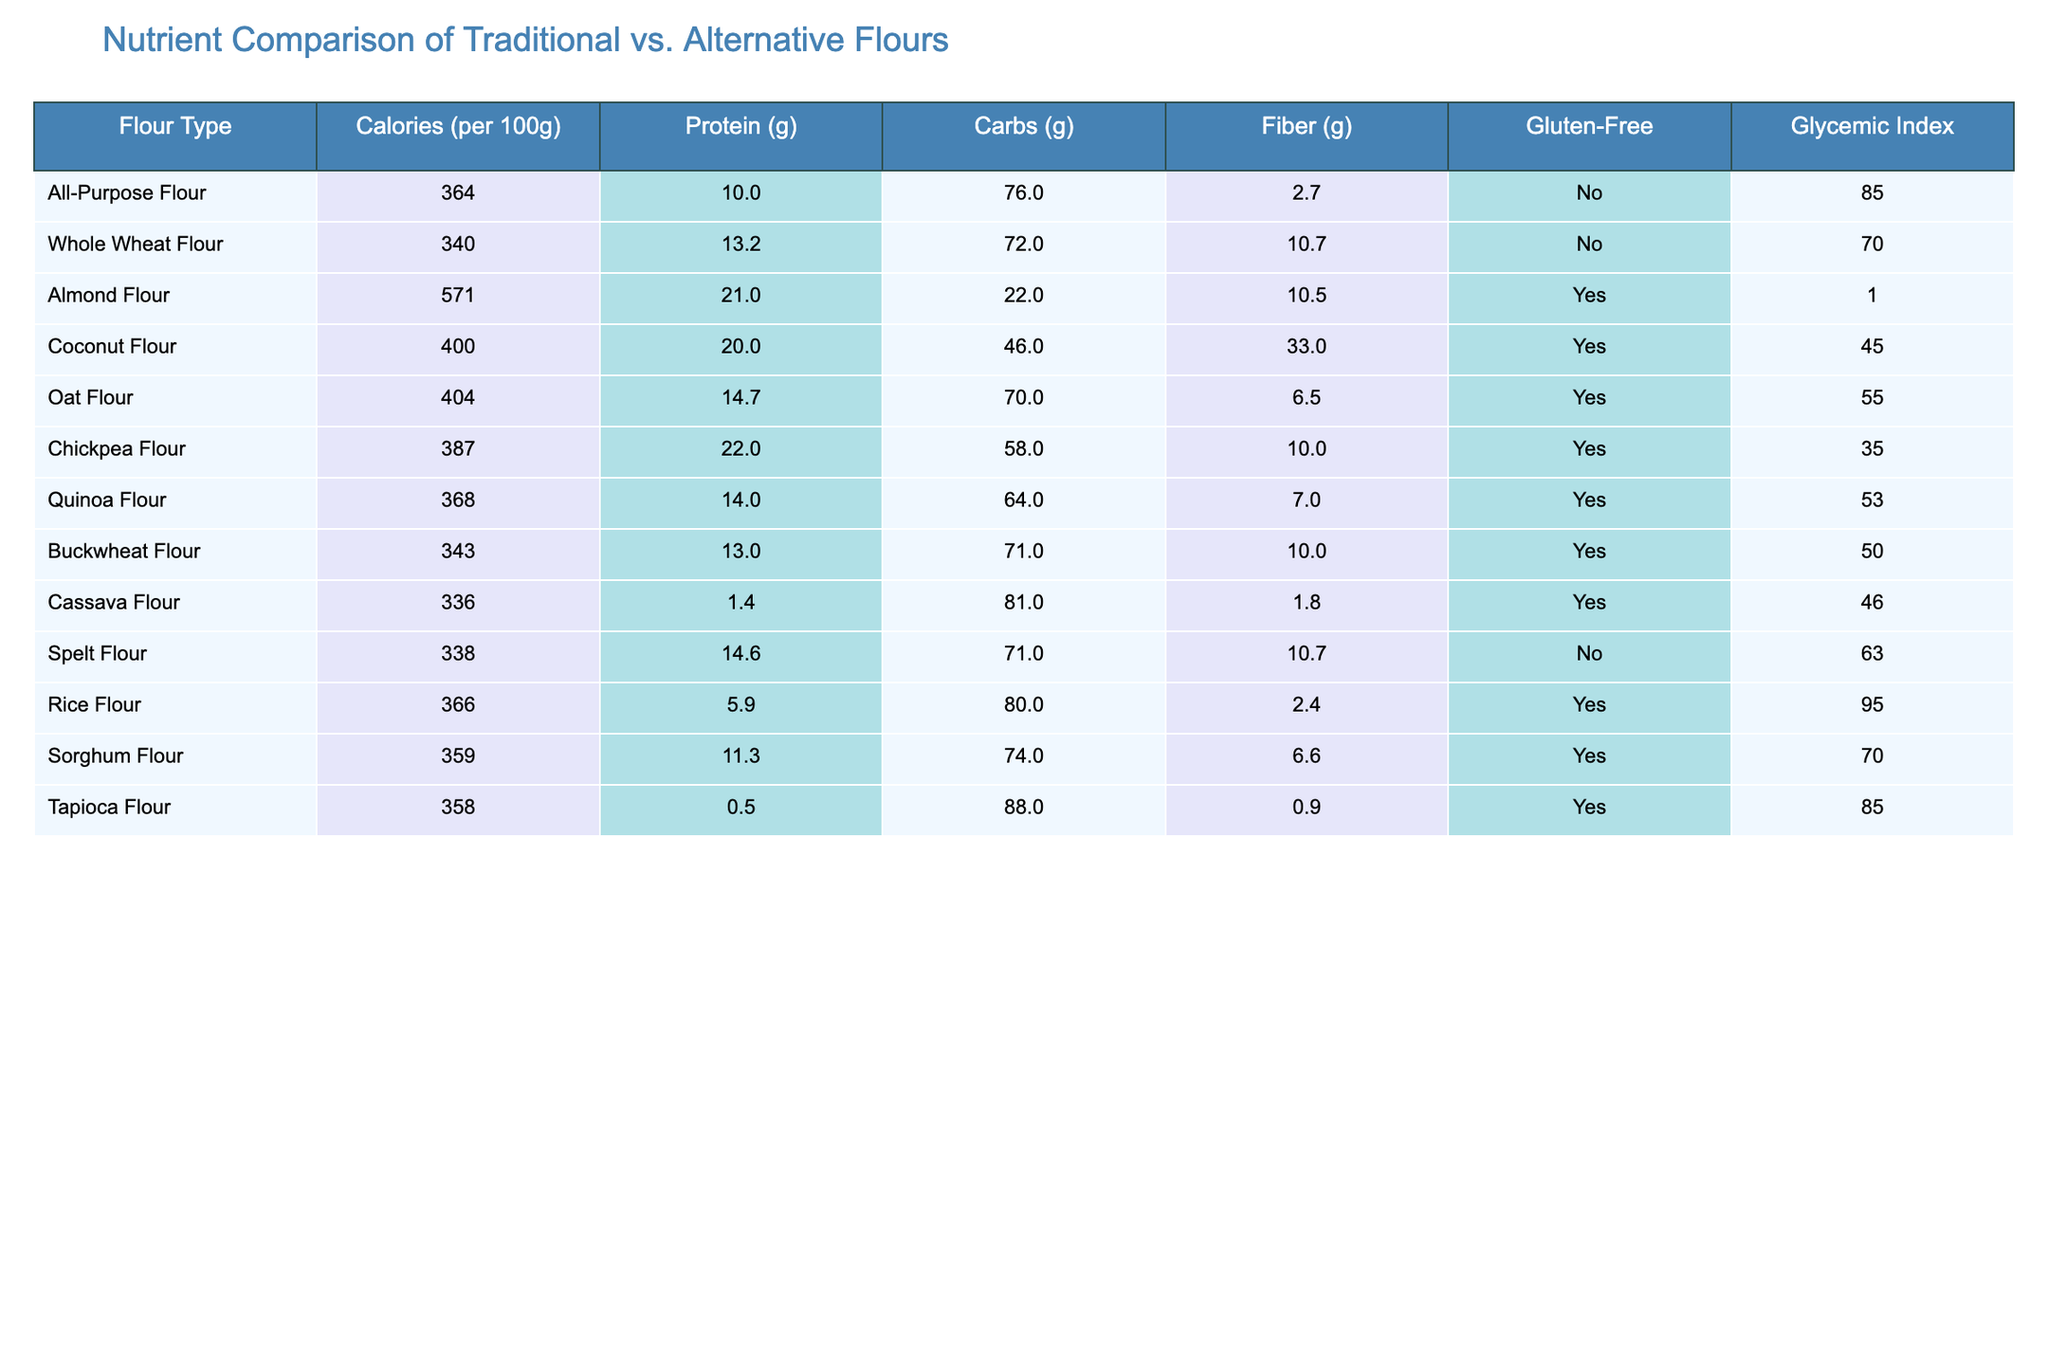What is the calorie content of Almond Flour? According to the table, Almond Flour has a calorie content of 571 calories per 100g.
Answer: 571 Which flour has the highest protein content? The table shows that Almond Flour has the highest protein content at 21g per 100g, compared to the other flours listed.
Answer: Almond Flour Is Coconut Flour gluten-free? The table indicates that Coconut Flour is labeled as gluten-free.
Answer: Yes What is the average glycemic index of the flours listed? To find the average glycemic index, sum the glycemic indices of all flours (85 + 70 + 1 + 45 + 55 + 35 + 53 + 50 + 46 + 63 + 95 + 70 + 85 =  588) and divide by the number of flours (13). Therefore, 588/13 ≈ 45.23.
Answer: 45.23 Which flour type has the lowest carbohydrate content? Analyzing the carbohydrates listed, Almond Flour has 22g, which is the lowest amount compared to other flours listed.
Answer: Almond Flour Is Rice Flour the only flour with a glycemic index higher than 90? The table shows that Rice Flour has a glycemic index of 95 and none of the other flours have a glycemic index above this value, making this statement true.
Answer: Yes What is the difference in fiber content between Whole Wheat Flour and Chickpea Flour? Whole Wheat Flour has 10.7g of fiber, while Chickpea Flour has 10g. The difference is 10.7g - 10g = 0.7g.
Answer: 0.7g How many flours listed are gluten-free? The table specifies 8 out of the 13 flours are marked as gluten-free.
Answer: 8 What flour has the highest calorie content, and what is its fiber content? Almond Flour has the highest calorie content at 571. Its fiber content is 10.5g.
Answer: Almond Flour, 10.5g Are there any flours that contain more than 70g of carbohydrates but less than 5g of protein? By examining the table, we see that both Tapioca Flour and Cassava Flour have more than 70g of carbohydrates (88g and 81g, respectively) with only 0.5g and 1.4g of protein.
Answer: Yes 